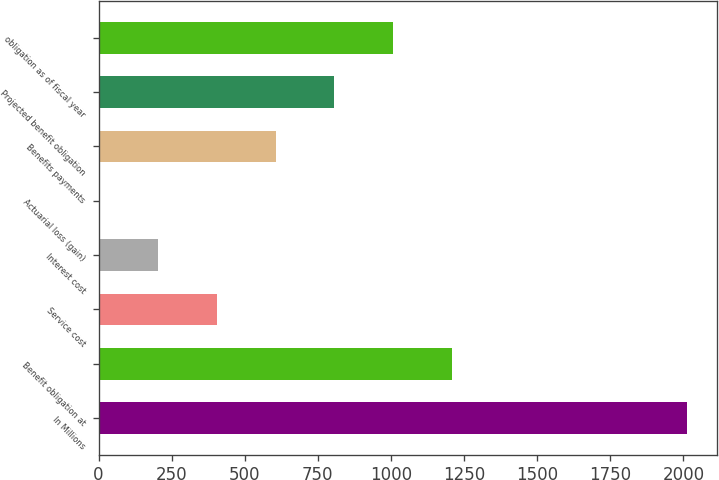Convert chart. <chart><loc_0><loc_0><loc_500><loc_500><bar_chart><fcel>In Millions<fcel>Benefit obligation at<fcel>Service cost<fcel>Interest cost<fcel>Actuarial loss (gain)<fcel>Benefits payments<fcel>Projected benefit obligation<fcel>obligation as of fiscal year<nl><fcel>2014<fcel>1209.12<fcel>404.24<fcel>203.02<fcel>1.8<fcel>605.46<fcel>806.68<fcel>1007.9<nl></chart> 